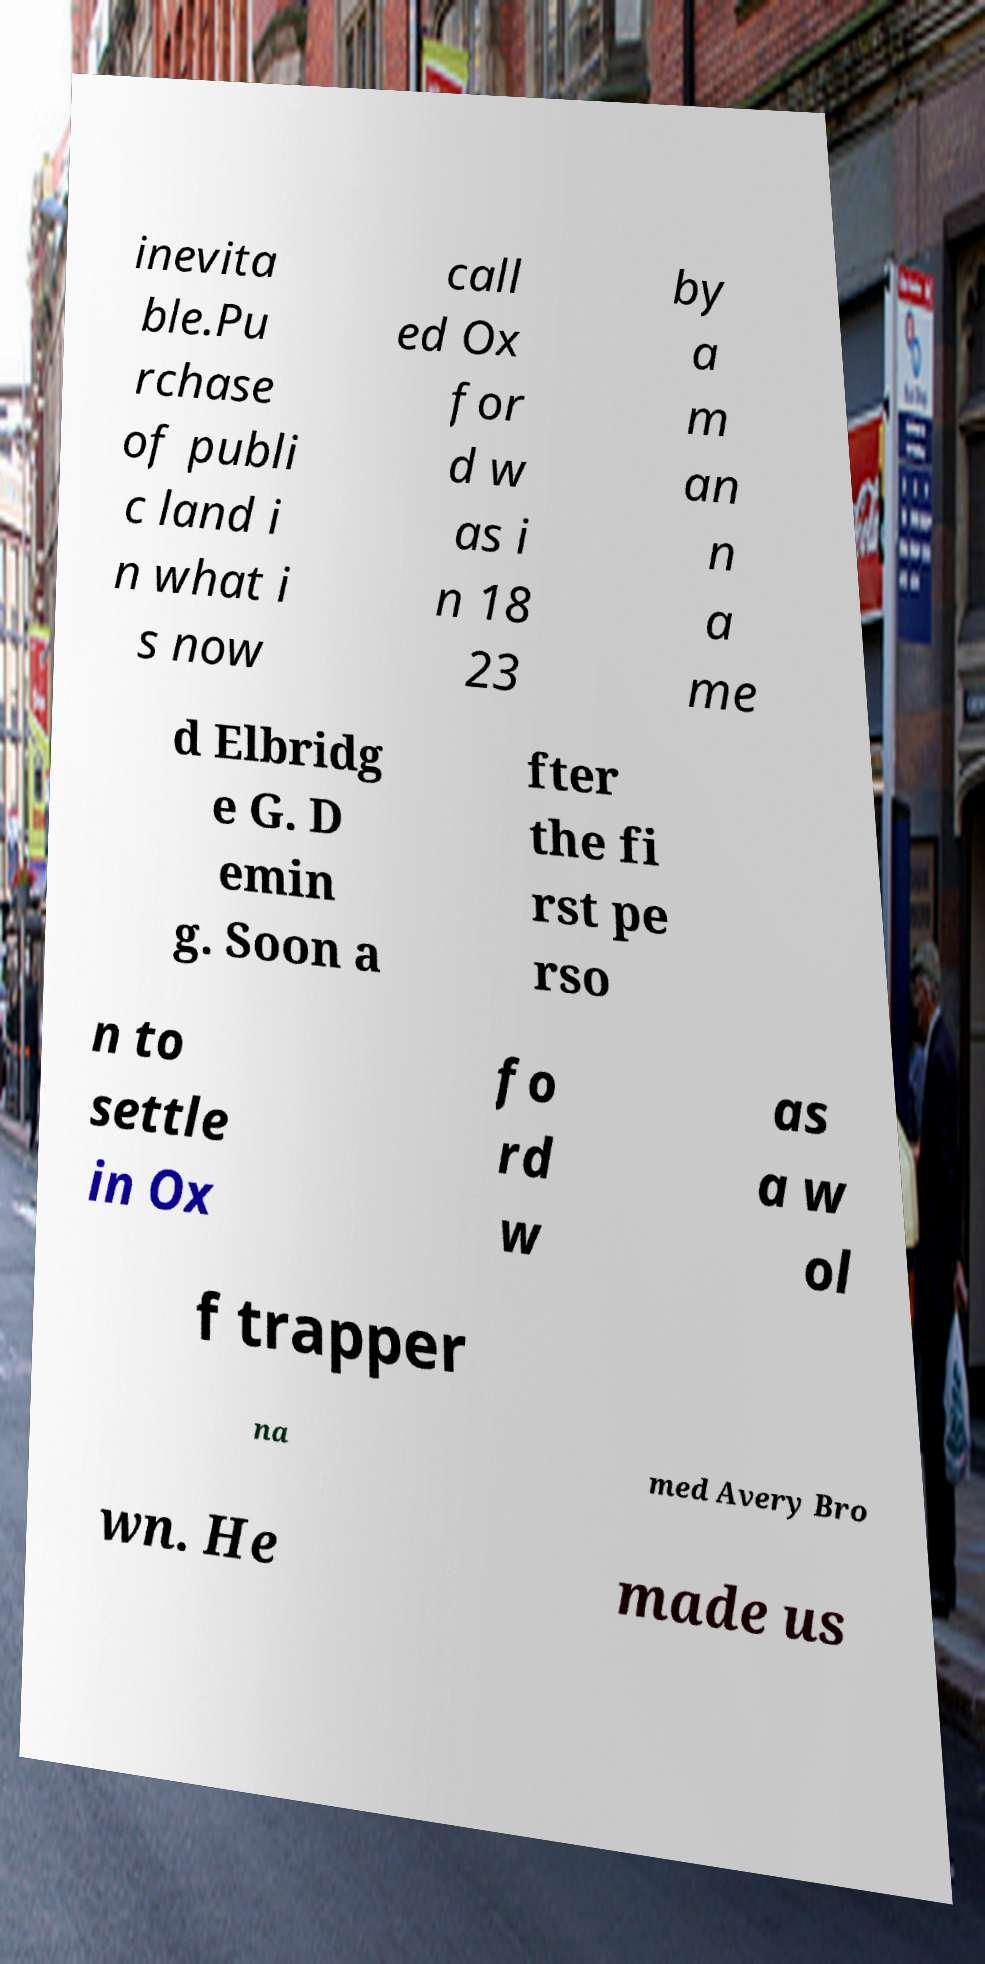For documentation purposes, I need the text within this image transcribed. Could you provide that? inevita ble.Pu rchase of publi c land i n what i s now call ed Ox for d w as i n 18 23 by a m an n a me d Elbridg e G. D emin g. Soon a fter the fi rst pe rso n to settle in Ox fo rd w as a w ol f trapper na med Avery Bro wn. He made us 